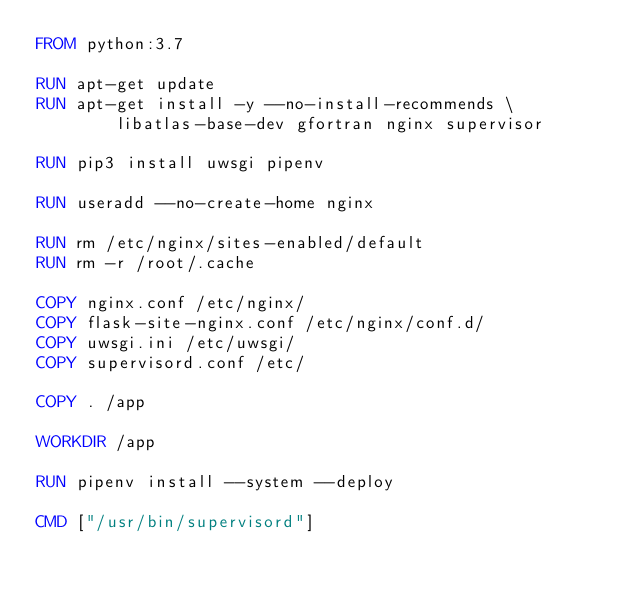Convert code to text. <code><loc_0><loc_0><loc_500><loc_500><_Dockerfile_>FROM python:3.7

RUN apt-get update
RUN apt-get install -y --no-install-recommends \
        libatlas-base-dev gfortran nginx supervisor

RUN pip3 install uwsgi pipenv

RUN useradd --no-create-home nginx

RUN rm /etc/nginx/sites-enabled/default
RUN rm -r /root/.cache

COPY nginx.conf /etc/nginx/
COPY flask-site-nginx.conf /etc/nginx/conf.d/
COPY uwsgi.ini /etc/uwsgi/
COPY supervisord.conf /etc/

COPY . /app

WORKDIR /app

RUN pipenv install --system --deploy

CMD ["/usr/bin/supervisord"]
</code> 